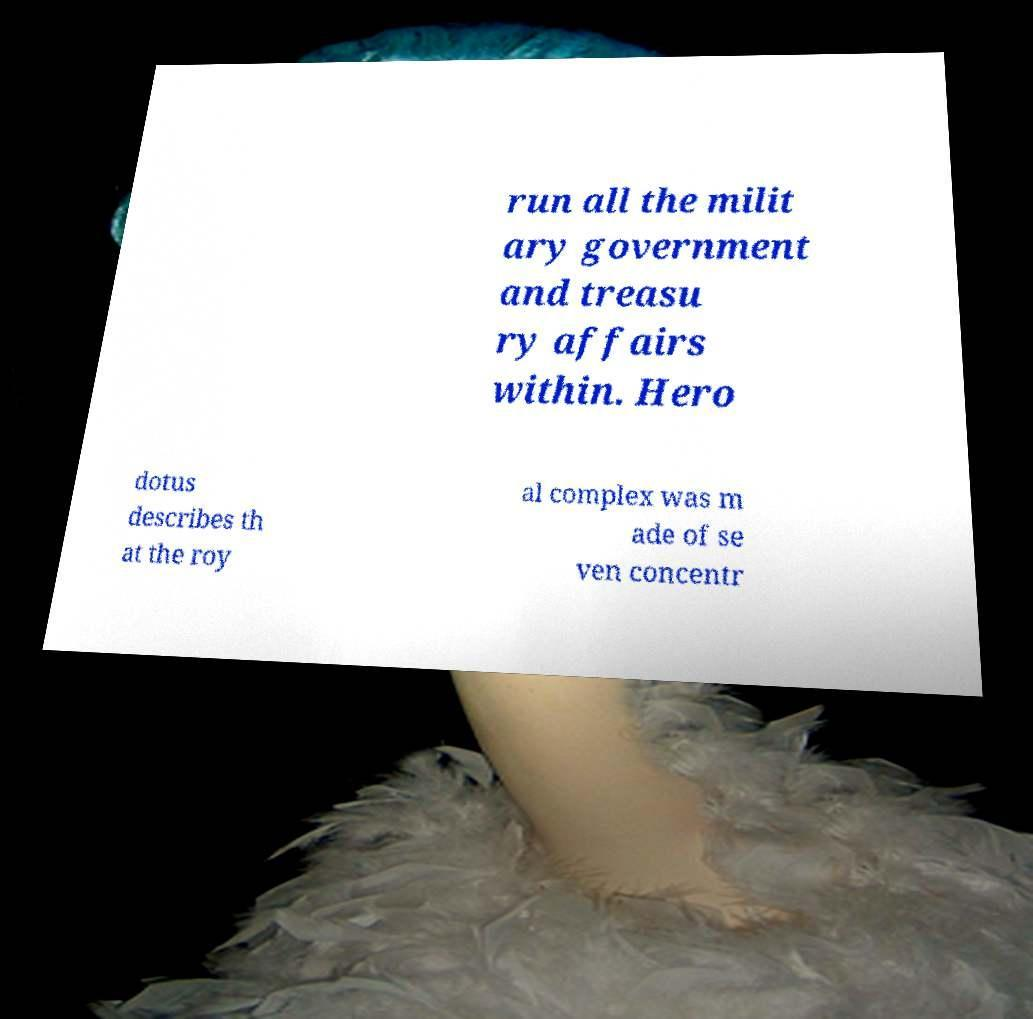Can you accurately transcribe the text from the provided image for me? run all the milit ary government and treasu ry affairs within. Hero dotus describes th at the roy al complex was m ade of se ven concentr 